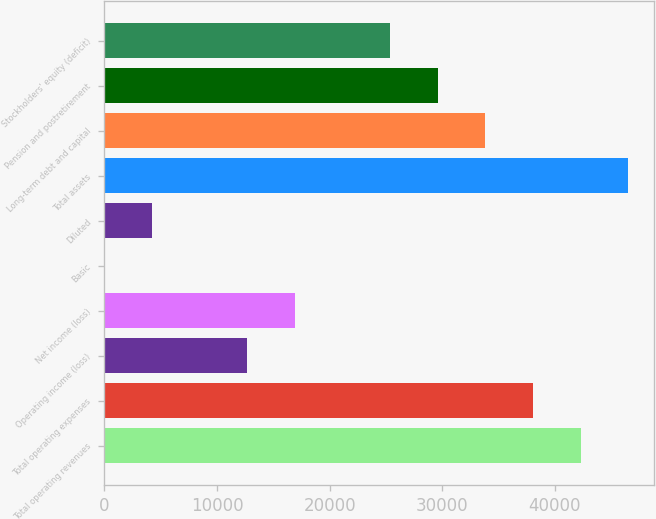Convert chart. <chart><loc_0><loc_0><loc_500><loc_500><bar_chart><fcel>Total operating revenues<fcel>Total operating expenses<fcel>Operating income (loss)<fcel>Net income (loss)<fcel>Basic<fcel>Diluted<fcel>Total assets<fcel>Long-term debt and capital<fcel>Pension and postretirement<fcel>Stockholders' equity (deficit)<nl><fcel>42278<fcel>38050.9<fcel>12688<fcel>16915.1<fcel>6.54<fcel>4233.69<fcel>46505.2<fcel>33823.7<fcel>29596.6<fcel>25369.4<nl></chart> 